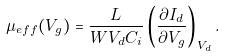Convert formula to latex. <formula><loc_0><loc_0><loc_500><loc_500>\mu _ { e f f } ( V _ { g } ) = \frac { L } { W V _ { d } C _ { i } } \left ( \frac { \partial I _ { d } } { \partial V _ { g } } \right ) _ { V _ { d } } .</formula> 